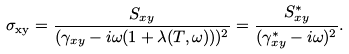<formula> <loc_0><loc_0><loc_500><loc_500>\sigma _ { \text {xy} } = \frac { S _ { x y } } { ( \gamma _ { x y } - i \omega ( 1 + \lambda ( T , \omega ) ) ) ^ { 2 } } = \frac { S ^ { * } _ { x y } } { ( \gamma ^ { * } _ { x y } - i \omega ) ^ { 2 } } .</formula> 